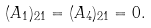<formula> <loc_0><loc_0><loc_500><loc_500>( A _ { 1 } ) _ { 2 1 } = ( A _ { 4 } ) _ { 2 1 } = 0 .</formula> 